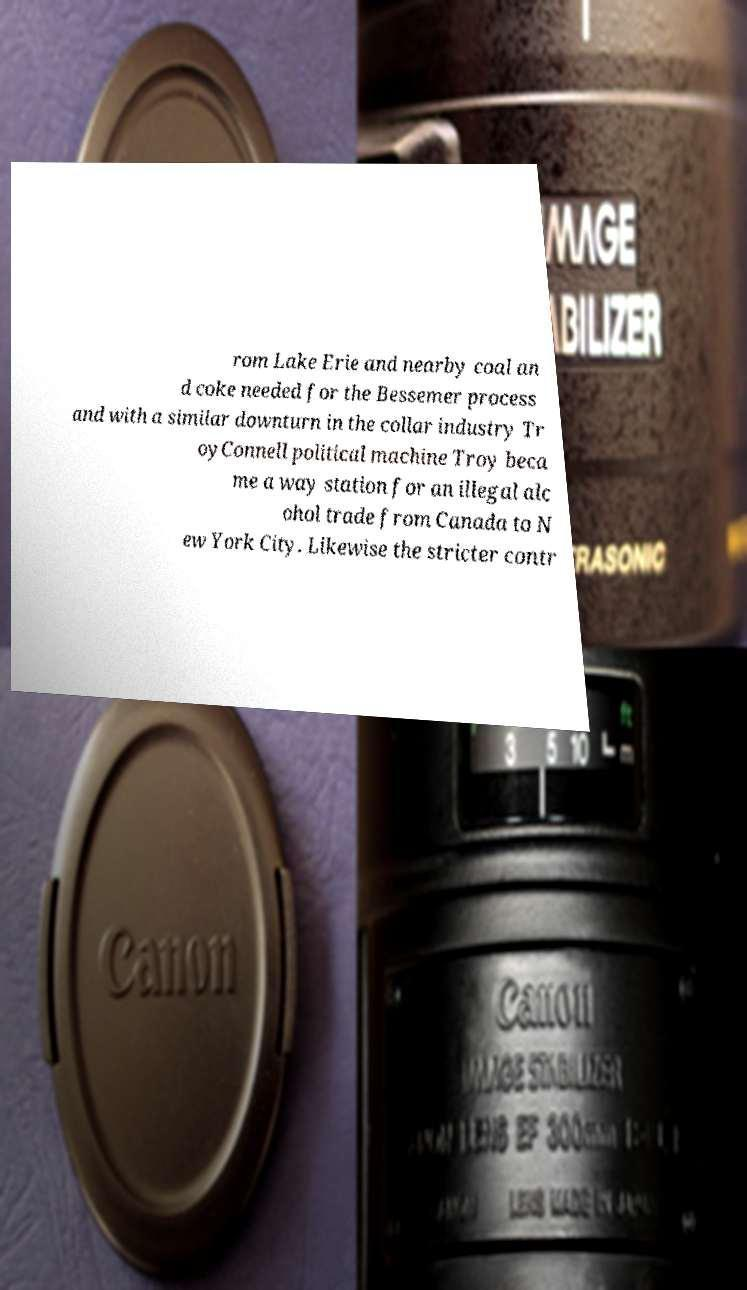For documentation purposes, I need the text within this image transcribed. Could you provide that? rom Lake Erie and nearby coal an d coke needed for the Bessemer process and with a similar downturn in the collar industry Tr oyConnell political machine Troy beca me a way station for an illegal alc ohol trade from Canada to N ew York City. Likewise the stricter contr 